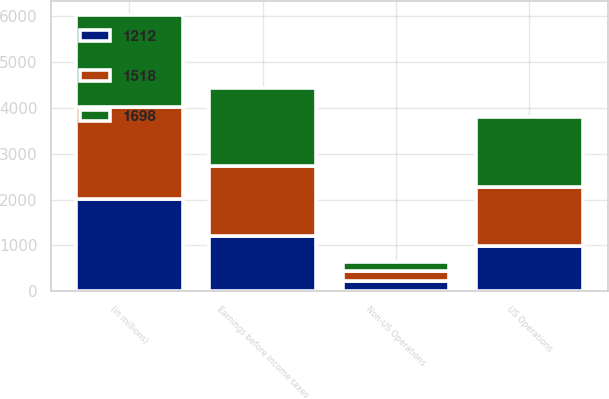<chart> <loc_0><loc_0><loc_500><loc_500><stacked_bar_chart><ecel><fcel>(in millions)<fcel>US Operations<fcel>Non-US Operations<fcel>Earnings before income taxes<nl><fcel>1698<fcel>2012<fcel>1514<fcel>184<fcel>1698<nl><fcel>1518<fcel>2011<fcel>1299<fcel>219<fcel>1518<nl><fcel>1212<fcel>2010<fcel>980<fcel>232<fcel>1212<nl></chart> 